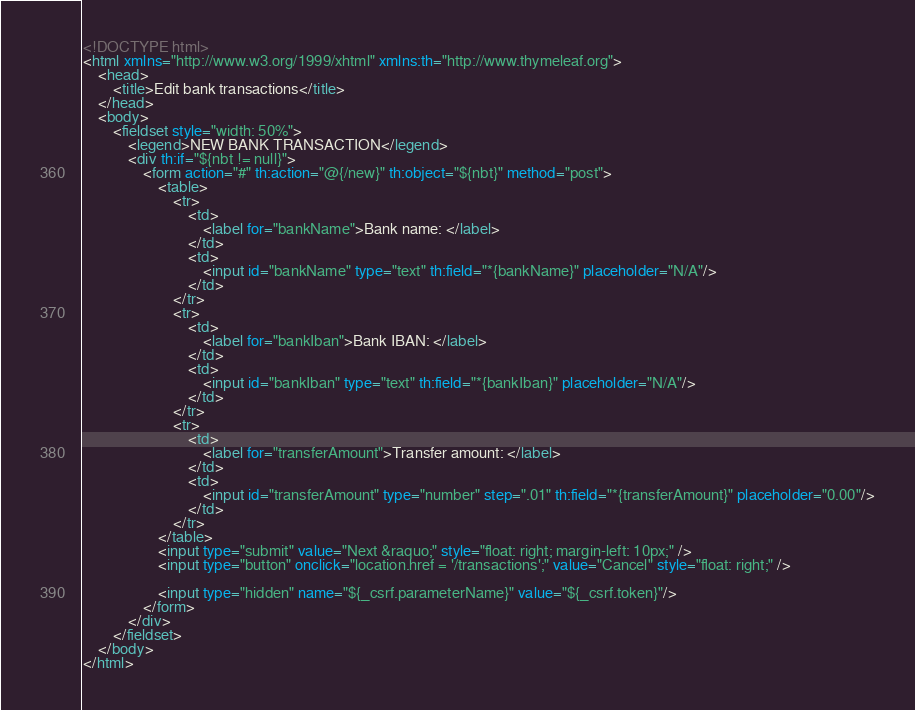<code> <loc_0><loc_0><loc_500><loc_500><_HTML_><!DOCTYPE html>
<html xmlns="http://www.w3.org/1999/xhtml" xmlns:th="http://www.thymeleaf.org">
    <head>
        <title>Edit bank transactions</title>        
    </head>
    <body>                
        <fieldset style="width: 50%">            
            <legend>NEW BANK TRANSACTION</legend>
            <div th:if="${nbt != null}">                                       
                <form action="#" th:action="@{/new}" th:object="${nbt}" method="post">
                    <table>
                        <tr>
                            <td>
                                <label for="bankName">Bank name: </label>
                            </td>
                            <td>
                                <input id="bankName" type="text" th:field="*{bankName}" placeholder="N/A"/>
                            </td>
                        </tr>
                        <tr>
                            <td>
                                <label for="bankIban">Bank IBAN: </label>
                            </td>
                            <td>
                                <input id="bankIban" type="text" th:field="*{bankIban}" placeholder="N/A"/>
                            </td>
                        </tr>                        
                        <tr>
                            <td>
                                <label for="transferAmount">Transfer amount: </label>
                            </td>
                            <td>
                                <input id="transferAmount" type="number" step=".01" th:field="*{transferAmount}" placeholder="0.00"/>
                            </td>
                        </tr>                        
                    </table>
                    <input type="submit" value="Next &raquo;" style="float: right; margin-left: 10px;" /> 
                    <input type="button" onclick="location.href = '/transactions';" value="Cancel" style="float: right;" />

                    <input type="hidden" name="${_csrf.parameterName}" value="${_csrf.token}"/>
                </form>  
            </div>
        </fieldset>
    </body>
</html></code> 